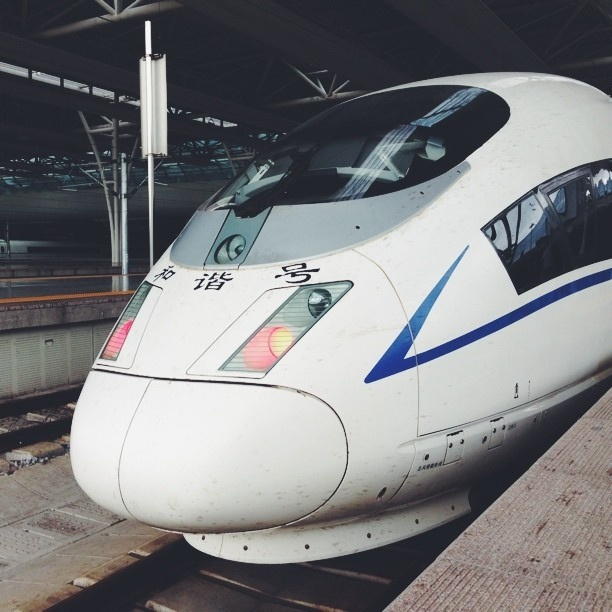Describe the objects in this image and their specific colors. I can see a train in black, lightgray, darkgray, and gray tones in this image. 